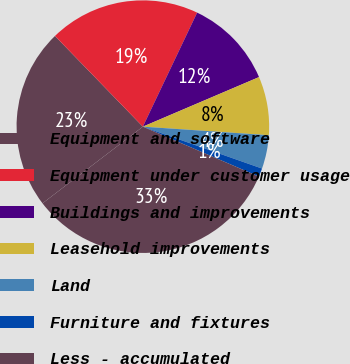Convert chart. <chart><loc_0><loc_0><loc_500><loc_500><pie_chart><fcel>Equipment and software<fcel>Equipment under customer usage<fcel>Buildings and improvements<fcel>Leasehold improvements<fcel>Land<fcel>Furniture and fixtures<fcel>Less - accumulated<nl><fcel>23.13%<fcel>19.32%<fcel>11.51%<fcel>7.5%<fcel>4.3%<fcel>1.09%<fcel>33.15%<nl></chart> 